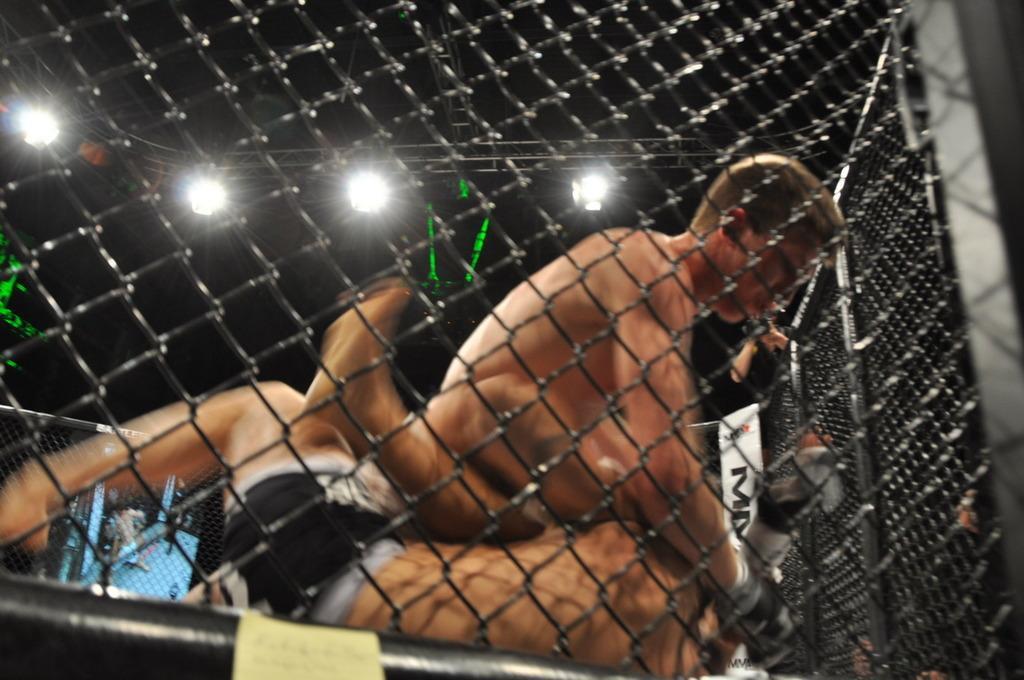In one or two sentences, can you explain what this image depicts? In the foreground there is a net fencing. Behind there are two men fighting. In the background there are few lights in the dark. 